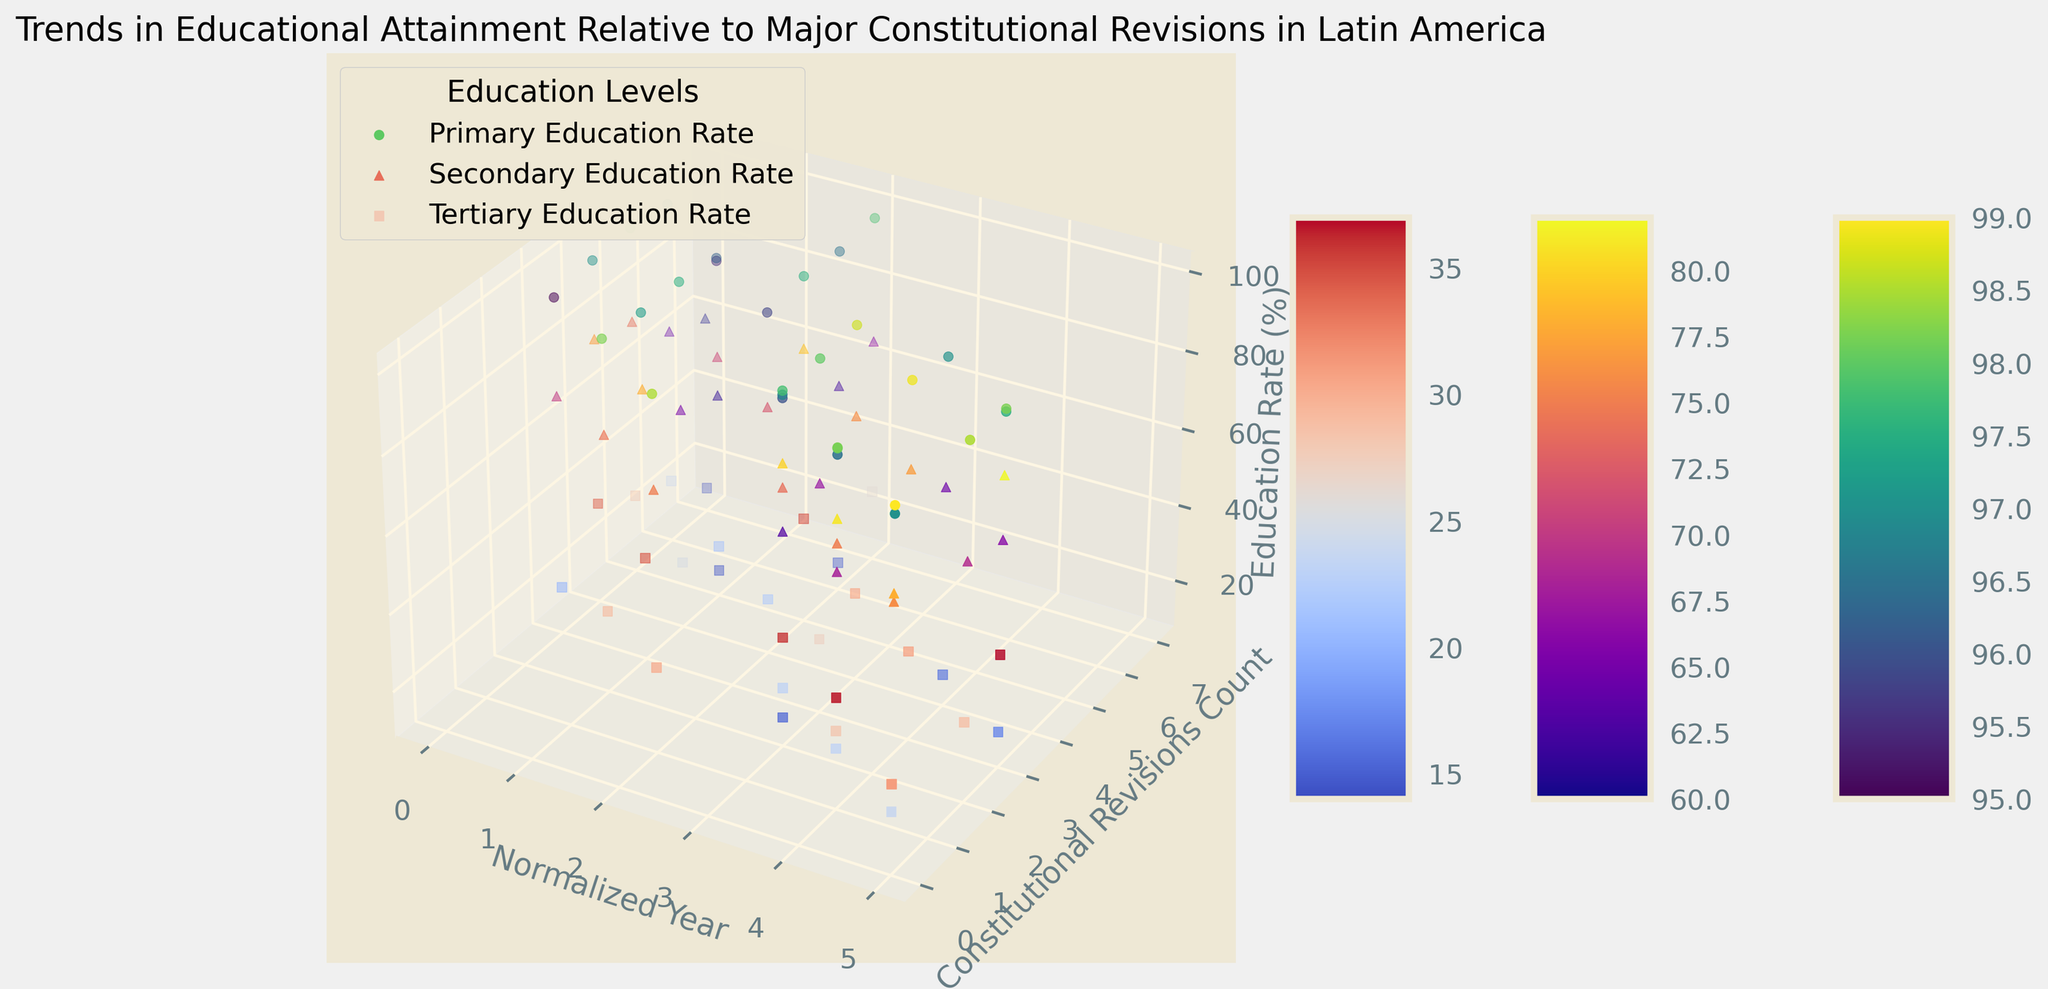What trend is observed for Argentina's secondary education rate from 2000 to 2005? Looking at the figure, each point for the secondary education rate in Argentina shows a gradual increase over time. Starting in 2000, the rate is at 74%, and by 2005 it increases to 78%. This trend indicates a consistent improvement.
Answer: Increasing Which country had the highest tertiary education rate in 2005? From the figure, observe the data points for 2005 and compare the tertiary education rates across the countries. Chile shows the highest rate with 37%, followed by Argentina (31%), Mexico (28.5%), Colombia (24%), and Brazil (17%).
Answer: Chile How does the primary education rate in Brazil change relative to the number of constitutional revisions between 2003 and 2005? The figure indicates that between 2003 and 2005, Brazil's primary education rate increases from 96.8% to 97.5%, while the count of constitutional revisions fluctuates, decreasing from 2 to 0 then up to 3. Despite the varying number of revisions, the education rate still shows an overall increase.
Answer: Increase Compare the visualization of secondary education rates and tertiary education rates for Colombia in 2005. From the figure, the secondary education rate for Colombia in 2005 is represented by a specific point which is higher than the corresponding point for the tertiary education rate. Specifically, the secondary rate is 76%, whereas the tertiary rate is 24%.
Answer: Secondary rate is higher What is the difference in primary education rates between Argentina and Mexico in 2005? To find the difference, observe the primary education rates for Argentina (99%) and Mexico (98.5%) in 2005 on the figure. The difference is 99% - 98.5% = 0.5%.
Answer: 0.5% How does the secondary education rate change in Chile when the number of constitutional revisions decreases from 5 to 1 between 2002 and 2004? Reviewing the figure, Chile's secondary education rate increases from 79.2% in 2002 to 81% in 2004, despite the decrease in constitutional revisions from 5 to 1. This shows a positive trend in the secondary education rate irrespective of the revisions count.
Answer: Increase What is the average tertiary education rate for Brazil from 2000 to 2005? To compute the average, sum the tertiary education rates for Brazil from 2000 to 2005 (14, 14.5, 15, 15.3, 16, 17) and divide by the number of years. The sum is 91.8 and the number of years is 6, so the average is 91.8 / 6 ≈ 15.3%.
Answer: 15.3% Which country shows the highest increase in primary education rate from 2000 to 2005? Using the figure, compare the increase in primary education rate for each country from 2000 to 2005. Argentina shows the increase from 98% to 99% (+1%), Brazil from 96% to 97.5% (+1.5%), Chile from 97% to 98.2% (+1.2%), Colombia from 95% to 97% (+2%), and Mexico from 97% to 98.5% (+1.5%). Colombia shows the highest increase.
Answer: Colombia 